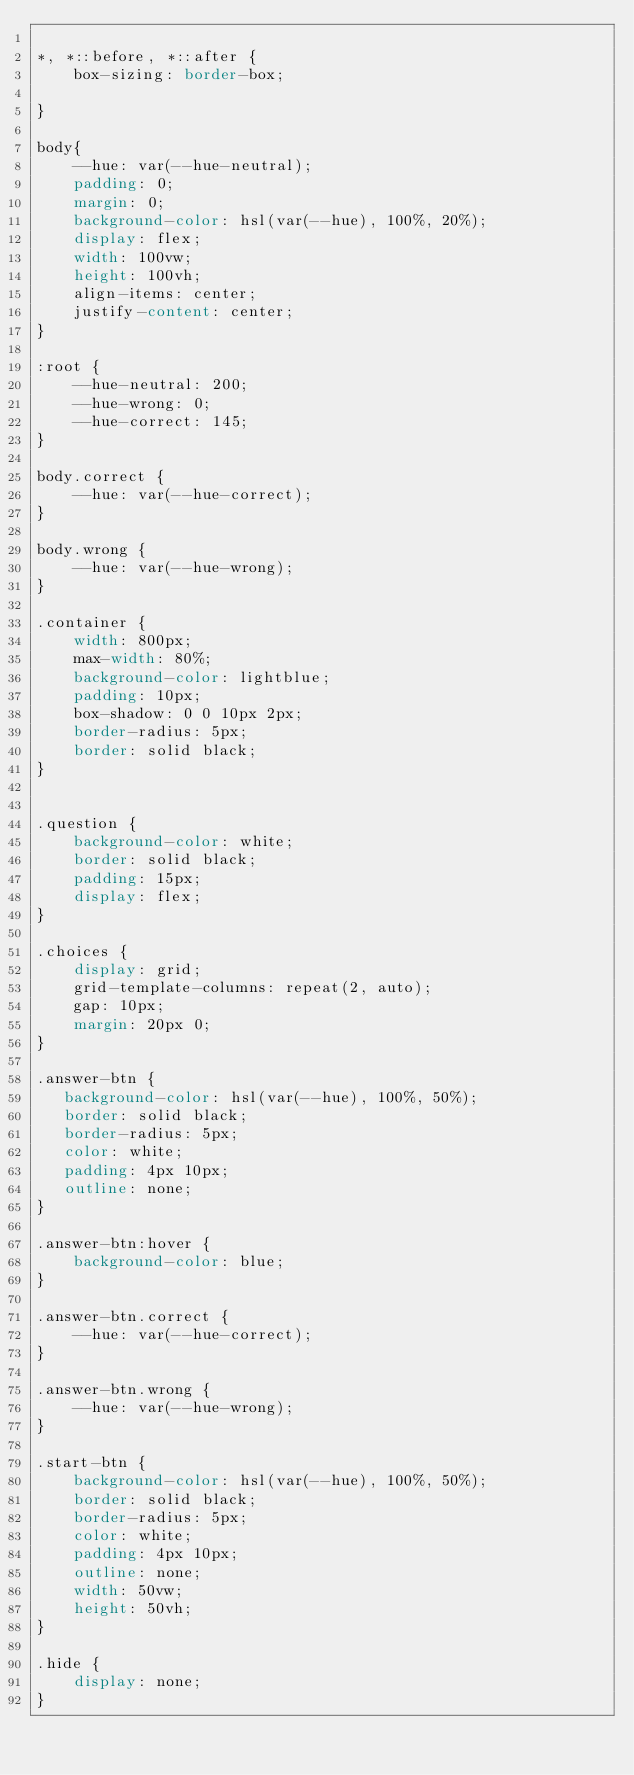Convert code to text. <code><loc_0><loc_0><loc_500><loc_500><_CSS_>
*, *::before, *::after {
    box-sizing: border-box;

}

body{
    --hue: var(--hue-neutral);
    padding: 0;
    margin: 0;
    background-color: hsl(var(--hue), 100%, 20%);
    display: flex;
    width: 100vw;
    height: 100vh;
    align-items: center;
    justify-content: center;
}

:root {
    --hue-neutral: 200;
    --hue-wrong: 0;
    --hue-correct: 145;
}

body.correct {
    --hue: var(--hue-correct);
}

body.wrong {
    --hue: var(--hue-wrong);
}

.container {
    width: 800px;
    max-width: 80%;
    background-color: lightblue;
    padding: 10px;
    box-shadow: 0 0 10px 2px;
    border-radius: 5px;
    border: solid black;
}


.question {
    background-color: white;
    border: solid black;
    padding: 15px;
    display: flex;
}

.choices {
    display: grid;
    grid-template-columns: repeat(2, auto);
    gap: 10px;
    margin: 20px 0;
}

.answer-btn {
   background-color: hsl(var(--hue), 100%, 50%);
   border: solid black;
   border-radius: 5px;
   color: white;
   padding: 4px 10px; 
   outline: none;
}

.answer-btn:hover {
    background-color: blue;
}

.answer-btn.correct {
    --hue: var(--hue-correct);
}

.answer-btn.wrong {
    --hue: var(--hue-wrong);
}

.start-btn {
    background-color: hsl(var(--hue), 100%, 50%);
    border: solid black;
    border-radius: 5px;
    color: white;
    padding: 4px 10px; 
    outline: none;  
    width: 50vw;
    height: 50vh;  
}

.hide {
    display: none;
}




</code> 